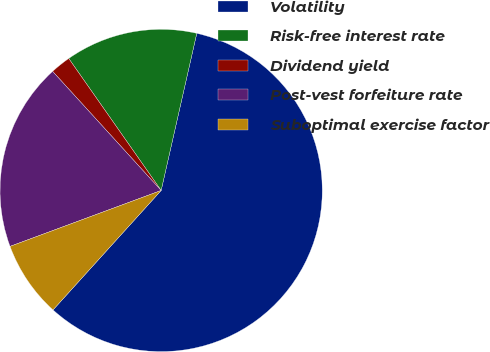<chart> <loc_0><loc_0><loc_500><loc_500><pie_chart><fcel>Volatility<fcel>Risk-free interest rate<fcel>Dividend yield<fcel>Post-vest forfeiture rate<fcel>Suboptimal exercise factor<nl><fcel>58.16%<fcel>13.27%<fcel>2.04%<fcel>18.88%<fcel>7.65%<nl></chart> 